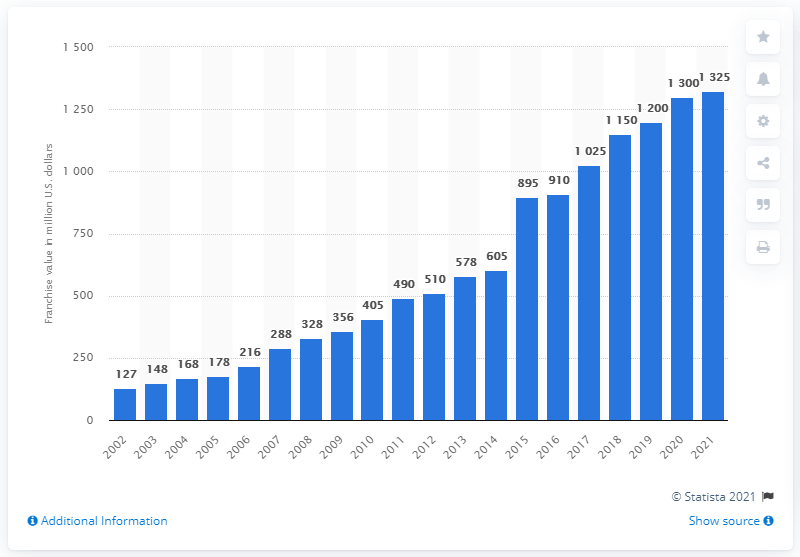Indicate a few pertinent items in this graphic. In 2021, the estimated value of the Minnesota Twins was approximately $1,325 million. 